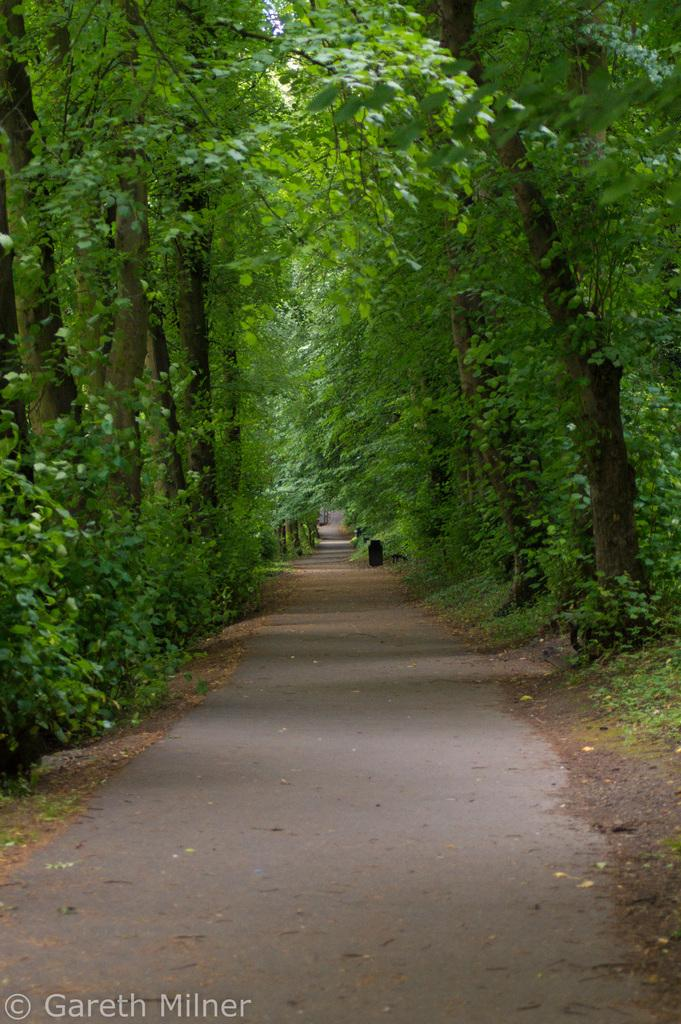What can be seen running through the area in the image? There is a path in the image. What type of vegetation is present alongside the path? There are trees on both sides of the path. What is present on the path itself? There are leaves on the path. What type of stocking is hanging from the tree on the left side of the path? There is no stocking hanging from the tree on the left side of the path in the image. 